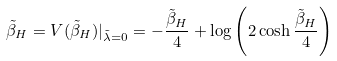Convert formula to latex. <formula><loc_0><loc_0><loc_500><loc_500>\tilde { \beta } _ { H } = V ( \tilde { \beta } _ { H } ) | _ { \tilde { \lambda } = 0 } = - \frac { \tilde { \beta } _ { H } } { 4 } + \log \left ( 2 \cosh \frac { \tilde { \beta } _ { H } } { 4 } \right )</formula> 